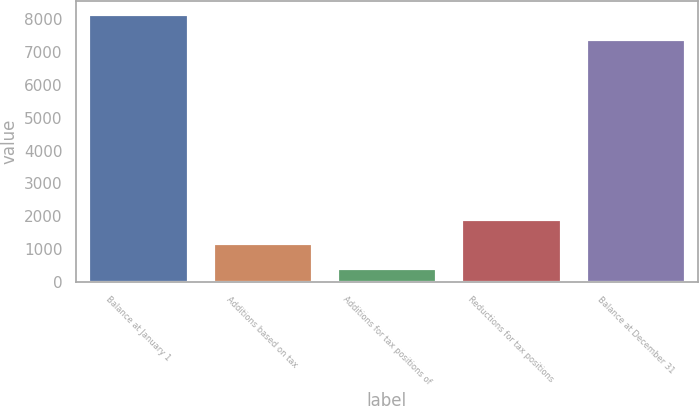Convert chart. <chart><loc_0><loc_0><loc_500><loc_500><bar_chart><fcel>Balance at January 1<fcel>Additions based on tax<fcel>Additions for tax positions of<fcel>Reductions for tax positions<fcel>Balance at December 31<nl><fcel>8153.4<fcel>1169.4<fcel>419<fcel>1919.8<fcel>7403<nl></chart> 